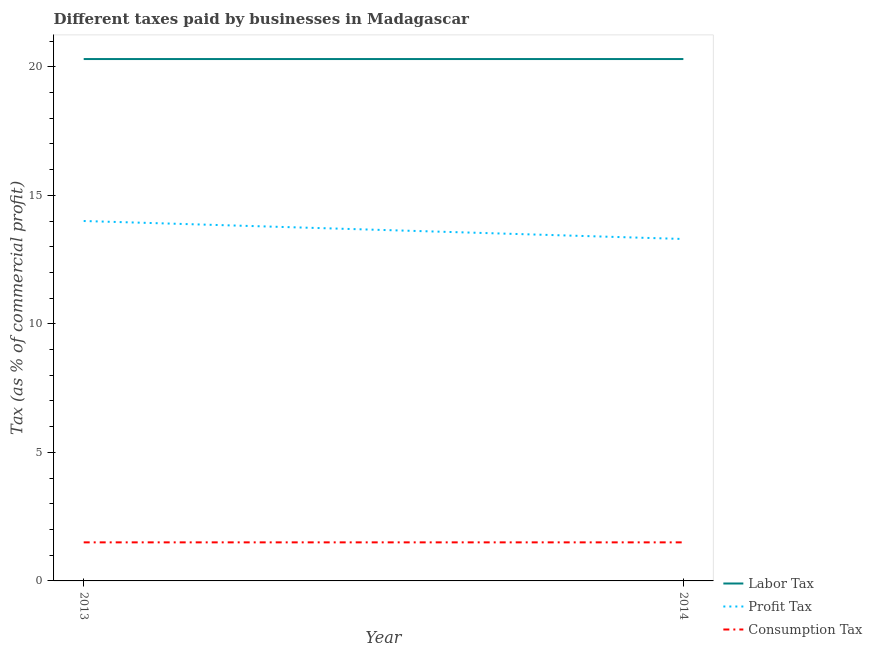Is the number of lines equal to the number of legend labels?
Your answer should be very brief. Yes. What is the percentage of profit tax in 2013?
Make the answer very short. 14. Across all years, what is the minimum percentage of profit tax?
Give a very brief answer. 13.3. In which year was the percentage of consumption tax minimum?
Your response must be concise. 2013. What is the total percentage of profit tax in the graph?
Keep it short and to the point. 27.3. What is the difference between the percentage of labor tax in 2013 and that in 2014?
Provide a succinct answer. 0. What is the difference between the percentage of labor tax in 2013 and the percentage of profit tax in 2014?
Your response must be concise. 7. What is the average percentage of profit tax per year?
Make the answer very short. 13.65. In the year 2013, what is the difference between the percentage of consumption tax and percentage of labor tax?
Keep it short and to the point. -18.8. What is the ratio of the percentage of profit tax in 2013 to that in 2014?
Offer a very short reply. 1.05. Is the percentage of profit tax in 2013 less than that in 2014?
Offer a terse response. No. Is it the case that in every year, the sum of the percentage of labor tax and percentage of profit tax is greater than the percentage of consumption tax?
Make the answer very short. Yes. Is the percentage of consumption tax strictly less than the percentage of labor tax over the years?
Your answer should be compact. Yes. What is the difference between two consecutive major ticks on the Y-axis?
Provide a short and direct response. 5. Are the values on the major ticks of Y-axis written in scientific E-notation?
Your answer should be very brief. No. How many legend labels are there?
Keep it short and to the point. 3. How are the legend labels stacked?
Your answer should be compact. Vertical. What is the title of the graph?
Offer a terse response. Different taxes paid by businesses in Madagascar. Does "Grants" appear as one of the legend labels in the graph?
Ensure brevity in your answer.  No. What is the label or title of the Y-axis?
Your response must be concise. Tax (as % of commercial profit). What is the Tax (as % of commercial profit) in Labor Tax in 2013?
Offer a very short reply. 20.3. What is the Tax (as % of commercial profit) in Profit Tax in 2013?
Your answer should be compact. 14. What is the Tax (as % of commercial profit) of Labor Tax in 2014?
Offer a terse response. 20.3. What is the Tax (as % of commercial profit) of Consumption Tax in 2014?
Offer a terse response. 1.5. Across all years, what is the maximum Tax (as % of commercial profit) of Labor Tax?
Give a very brief answer. 20.3. Across all years, what is the maximum Tax (as % of commercial profit) of Consumption Tax?
Ensure brevity in your answer.  1.5. Across all years, what is the minimum Tax (as % of commercial profit) of Labor Tax?
Offer a terse response. 20.3. What is the total Tax (as % of commercial profit) in Labor Tax in the graph?
Offer a very short reply. 40.6. What is the total Tax (as % of commercial profit) of Profit Tax in the graph?
Your answer should be very brief. 27.3. What is the difference between the Tax (as % of commercial profit) of Labor Tax in 2013 and that in 2014?
Your answer should be very brief. 0. What is the difference between the Tax (as % of commercial profit) of Profit Tax in 2013 and that in 2014?
Make the answer very short. 0.7. What is the difference between the Tax (as % of commercial profit) in Consumption Tax in 2013 and that in 2014?
Keep it short and to the point. 0. What is the difference between the Tax (as % of commercial profit) in Labor Tax in 2013 and the Tax (as % of commercial profit) in Profit Tax in 2014?
Give a very brief answer. 7. What is the difference between the Tax (as % of commercial profit) in Labor Tax in 2013 and the Tax (as % of commercial profit) in Consumption Tax in 2014?
Ensure brevity in your answer.  18.8. What is the average Tax (as % of commercial profit) in Labor Tax per year?
Your answer should be very brief. 20.3. What is the average Tax (as % of commercial profit) of Profit Tax per year?
Your answer should be compact. 13.65. What is the average Tax (as % of commercial profit) in Consumption Tax per year?
Provide a short and direct response. 1.5. In the year 2014, what is the difference between the Tax (as % of commercial profit) in Labor Tax and Tax (as % of commercial profit) in Profit Tax?
Offer a terse response. 7. In the year 2014, what is the difference between the Tax (as % of commercial profit) of Profit Tax and Tax (as % of commercial profit) of Consumption Tax?
Your answer should be very brief. 11.8. What is the ratio of the Tax (as % of commercial profit) in Labor Tax in 2013 to that in 2014?
Offer a very short reply. 1. What is the ratio of the Tax (as % of commercial profit) of Profit Tax in 2013 to that in 2014?
Your answer should be very brief. 1.05. What is the ratio of the Tax (as % of commercial profit) of Consumption Tax in 2013 to that in 2014?
Ensure brevity in your answer.  1. What is the difference between the highest and the second highest Tax (as % of commercial profit) of Labor Tax?
Provide a succinct answer. 0. What is the difference between the highest and the lowest Tax (as % of commercial profit) of Labor Tax?
Your answer should be compact. 0. 